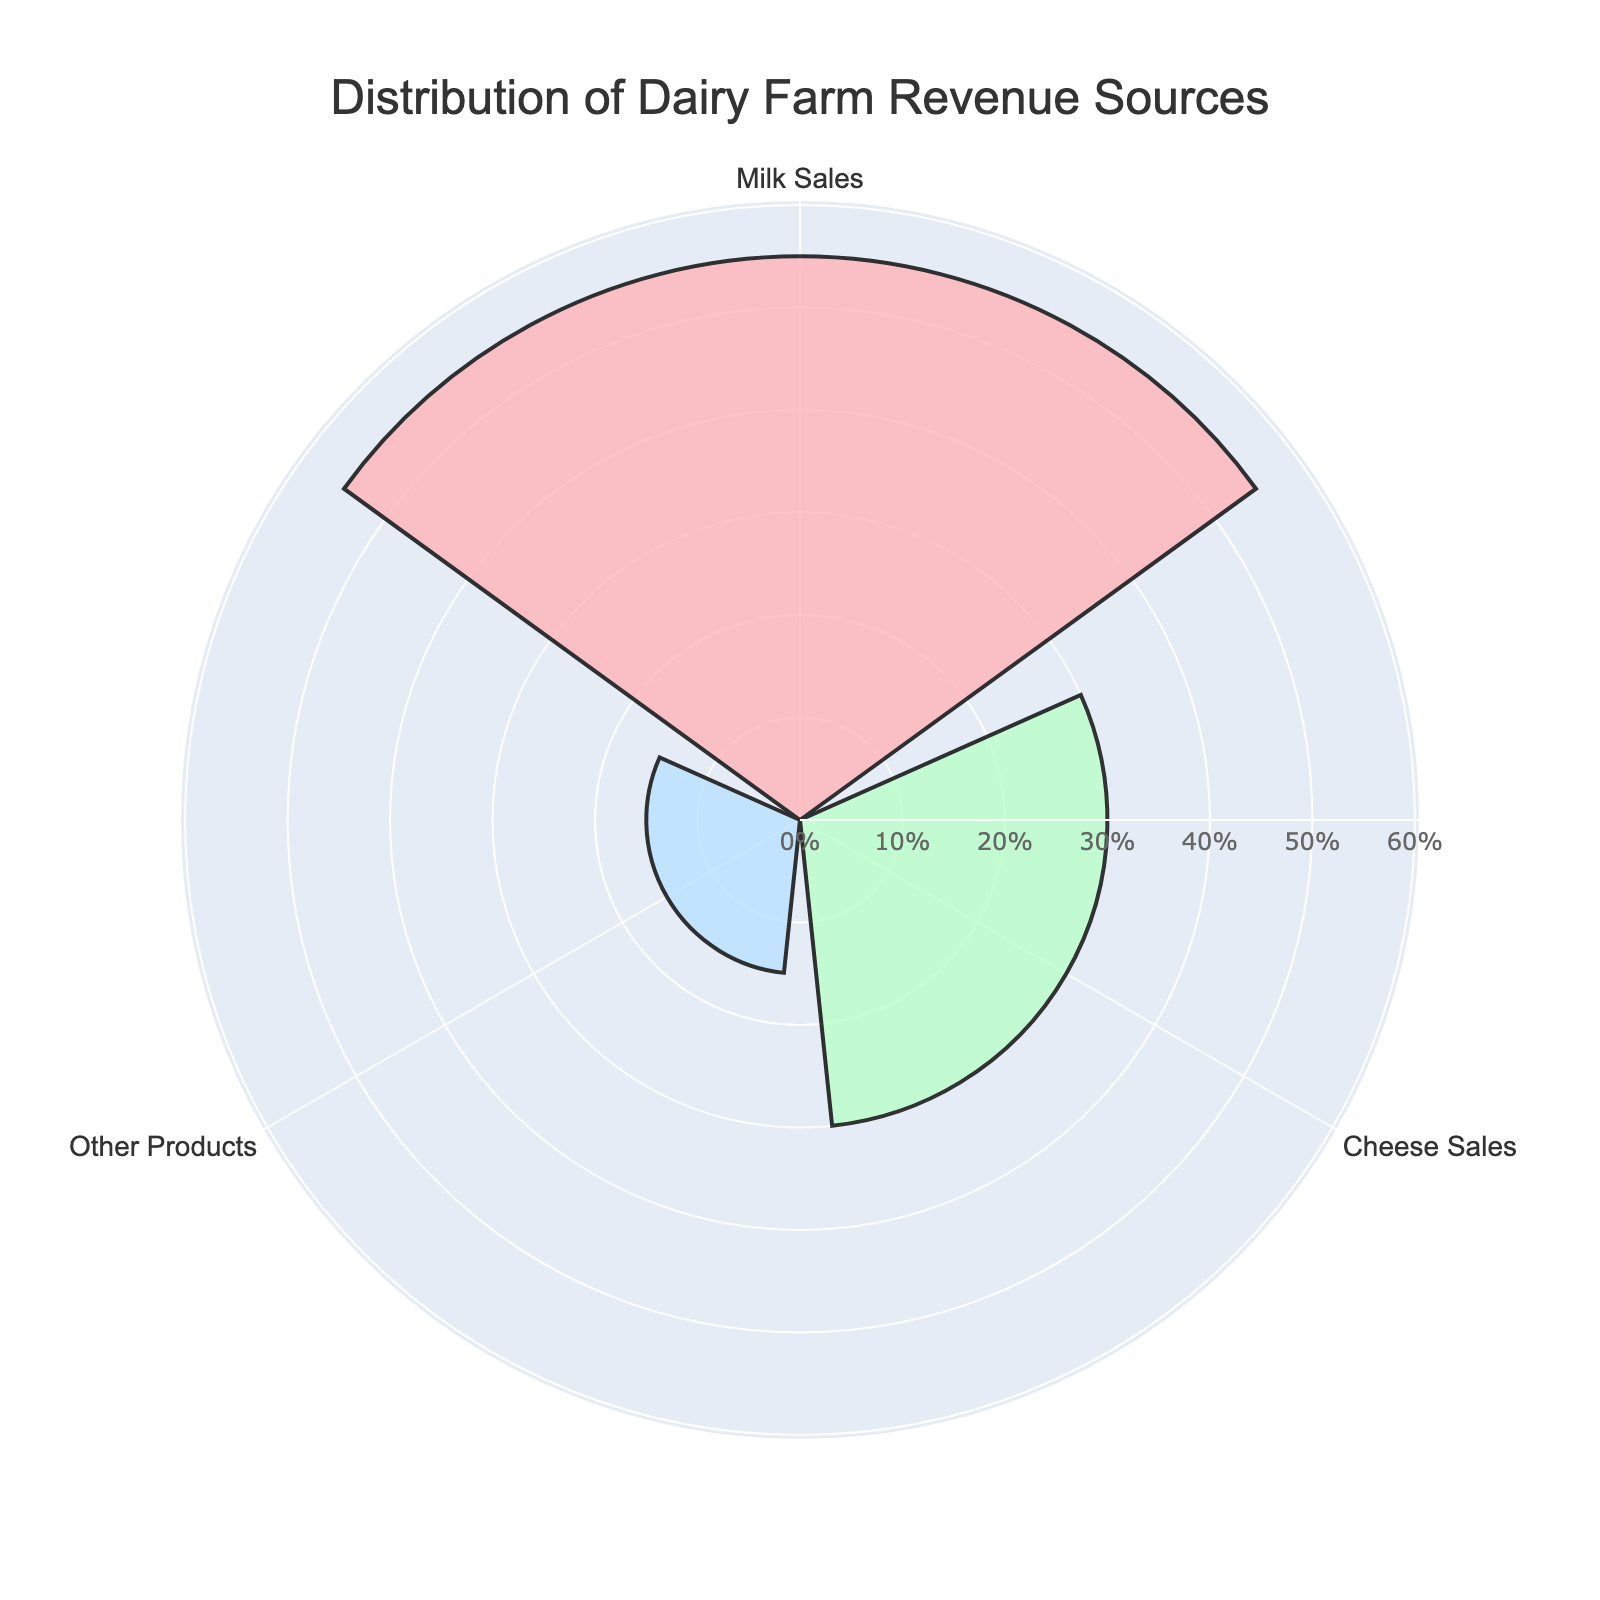Which revenue source contributes the most to dairy farm revenue? The figure shows the contributions in percentages. The largest segment in the rose chart represents 'Milk Sales' with 55%.
Answer: Milk Sales What percentage of the revenue comes from cheese sales? The figure annotations indicate that 'Cheese Sales' contribute 30% of the total revenue.
Answer: 30% How much more do milk sales contribute to the revenue compared to other products? From the figure, 'Milk Sales' are 55% and 'Other Products' are 15%. The difference is 55% - 15% = 40%.
Answer: 40% What proportion of the revenue is generated by products outside of milk and cheese sales combined? The figure shows 'Other Products' as 15% of the total revenue.
Answer: 15% How does the revenue from cheese sales compare to that from other products? The figure depicts 'Cheese Sales' at 30% and 'Other Products' at 15%. Thus, cheese sales are double the revenue of other products.
Answer: 30% is double 15% What is the total revenue percentage generated by milk and cheese sales combined? From the figure, Milk Sales contribute 55% and Cheese Sales contribute 30%. Adding them gives 55% + 30% = 85%.
Answer: 85% Which revenue source has the smallest contribution? The rose chart shows that 'Other Products' have the smallest contribution at 15%.
Answer: Other Products What is the average revenue percentage of all categories? The total revenue is divided into Milk Sales (55%), Cheese Sales (30%), and Other Products (15%). The average is (55% + 30% + 15%) / 3 = 100% / 3 = ~33.33%.
Answer: ~33.33% By what factor is the revenue from milk sales greater than that from other products? Revenue from milk sales is 55%, and from other products is 15%. Dividing these (55 / 15) gives approximately 3.67.
Answer: ~3.67 